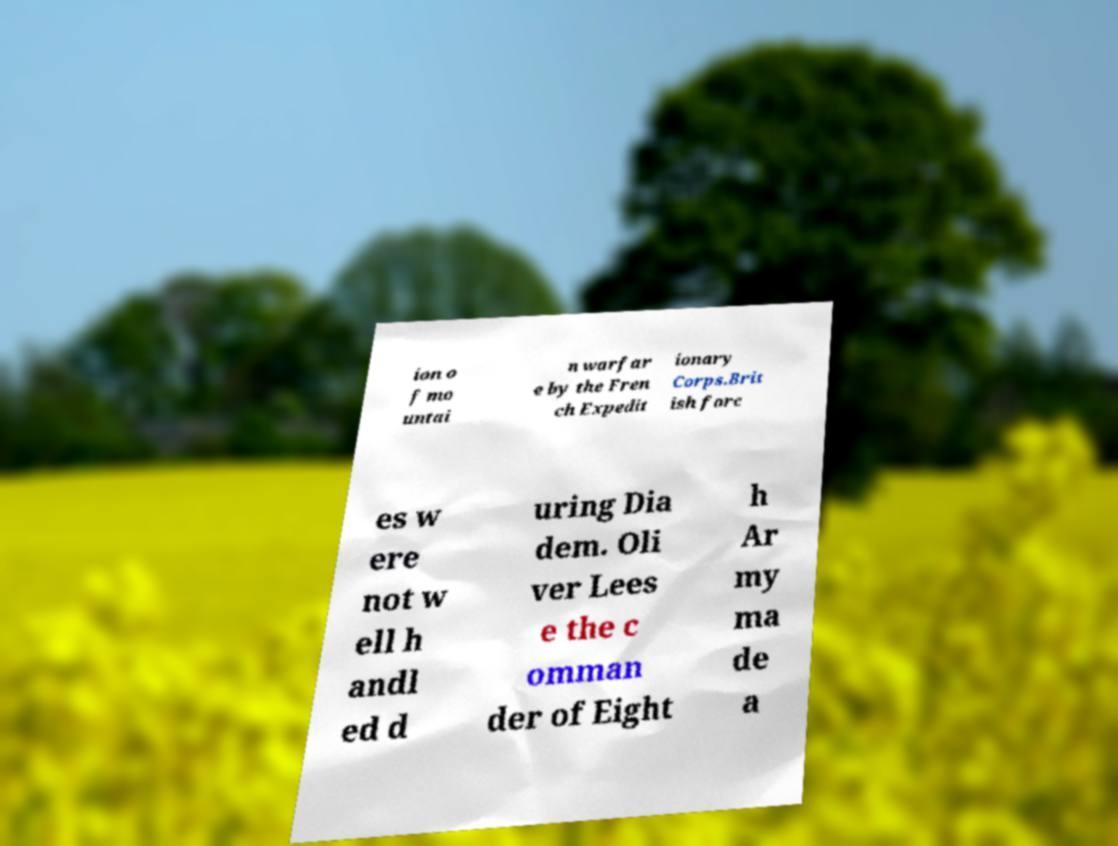Could you extract and type out the text from this image? ion o f mo untai n warfar e by the Fren ch Expedit ionary Corps.Brit ish forc es w ere not w ell h andl ed d uring Dia dem. Oli ver Lees e the c omman der of Eight h Ar my ma de a 